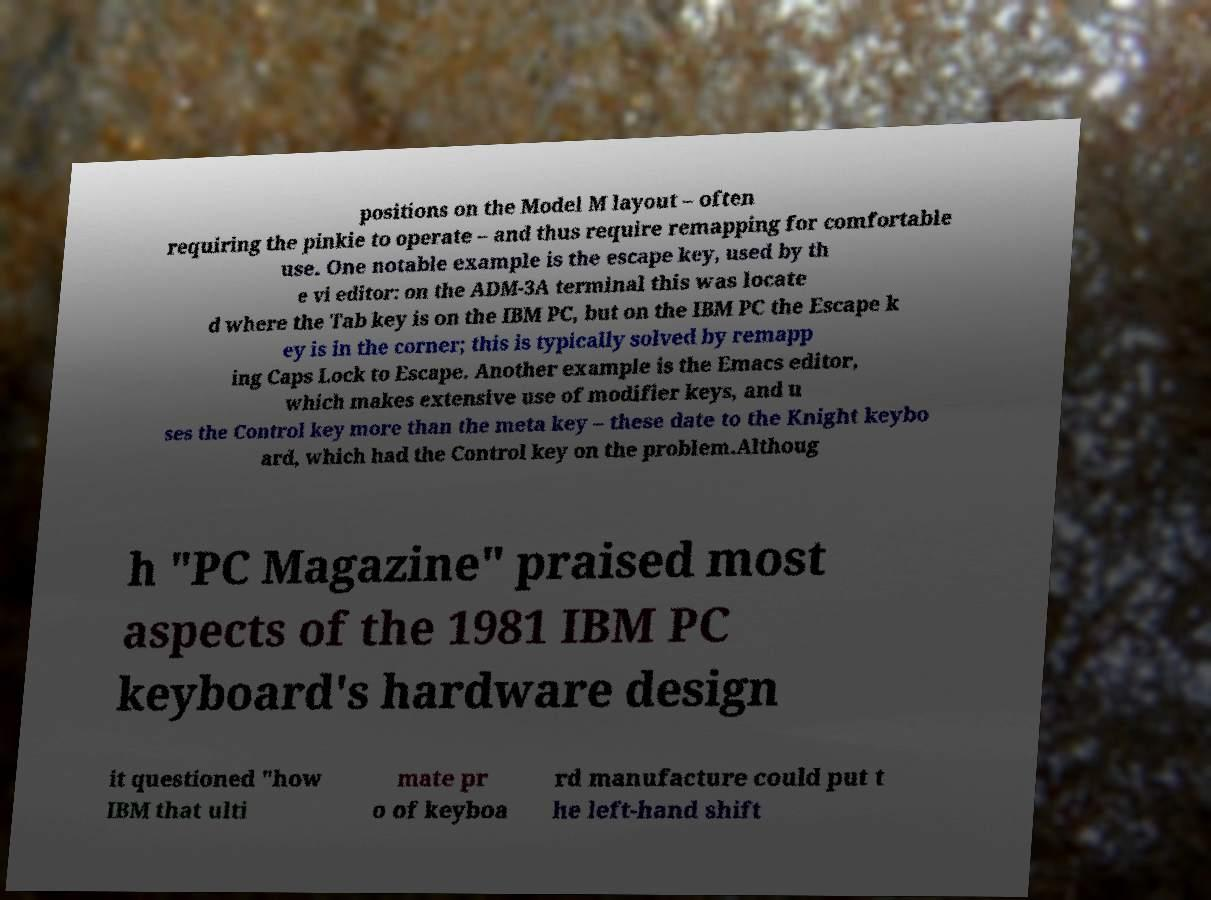There's text embedded in this image that I need extracted. Can you transcribe it verbatim? positions on the Model M layout – often requiring the pinkie to operate – and thus require remapping for comfortable use. One notable example is the escape key, used by th e vi editor: on the ADM-3A terminal this was locate d where the Tab key is on the IBM PC, but on the IBM PC the Escape k ey is in the corner; this is typically solved by remapp ing Caps Lock to Escape. Another example is the Emacs editor, which makes extensive use of modifier keys, and u ses the Control key more than the meta key – these date to the Knight keybo ard, which had the Control key on the problem.Althoug h "PC Magazine" praised most aspects of the 1981 IBM PC keyboard's hardware design it questioned "how IBM that ulti mate pr o of keyboa rd manufacture could put t he left-hand shift 